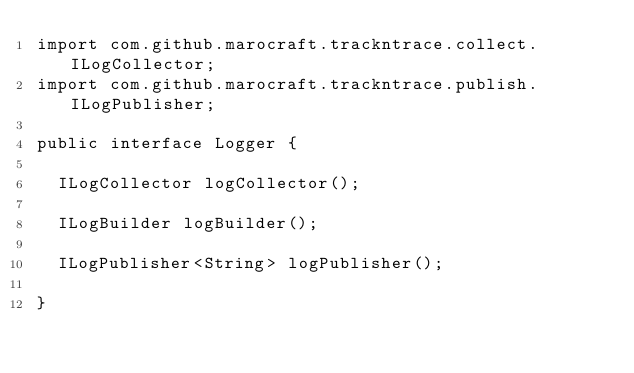<code> <loc_0><loc_0><loc_500><loc_500><_Java_>import com.github.marocraft.trackntrace.collect.ILogCollector;
import com.github.marocraft.trackntrace.publish.ILogPublisher;

public interface Logger {

	ILogCollector logCollector();

	ILogBuilder logBuilder();

	ILogPublisher<String> logPublisher();

}
</code> 